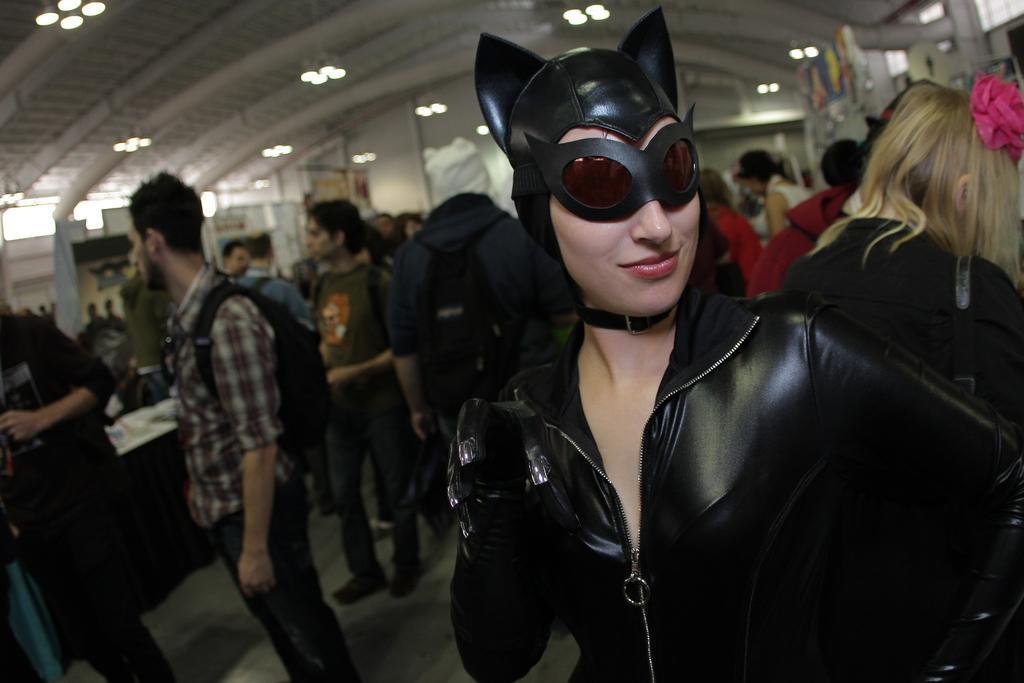Can you describe this image briefly? In this image there is one women standing at right side of this image is wearing black color dress and wearing black color mask, and there are some other persons at top right corner of this image and there are some persons at left side of this image and there is a table at left side of this image and there are some lights arranged at top of this image and there is a wall in the background. 